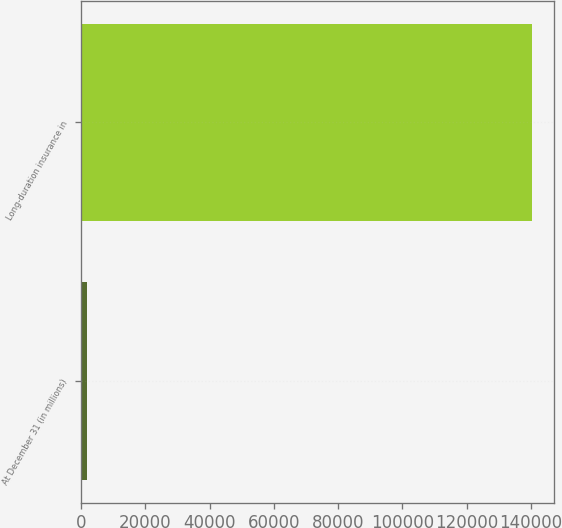Convert chart to OTSL. <chart><loc_0><loc_0><loc_500><loc_500><bar_chart><fcel>At December 31 (in millions)<fcel>Long-duration insurance in<nl><fcel>2011<fcel>140156<nl></chart> 